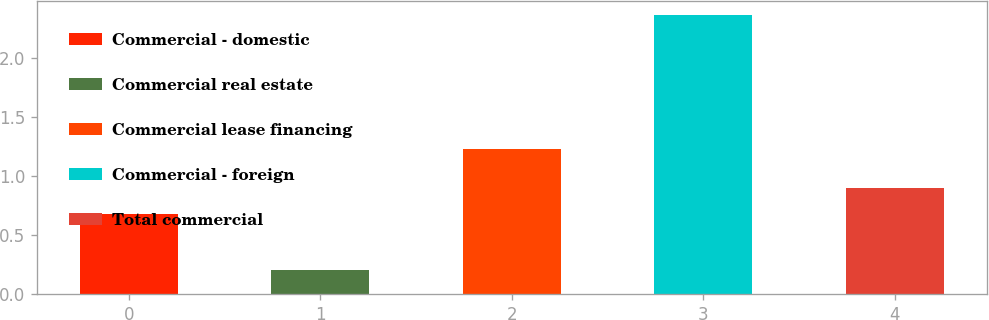Convert chart to OTSL. <chart><loc_0><loc_0><loc_500><loc_500><bar_chart><fcel>Commercial - domestic<fcel>Commercial real estate<fcel>Commercial lease financing<fcel>Commercial - foreign<fcel>Total commercial<nl><fcel>0.68<fcel>0.2<fcel>1.23<fcel>2.36<fcel>0.9<nl></chart> 